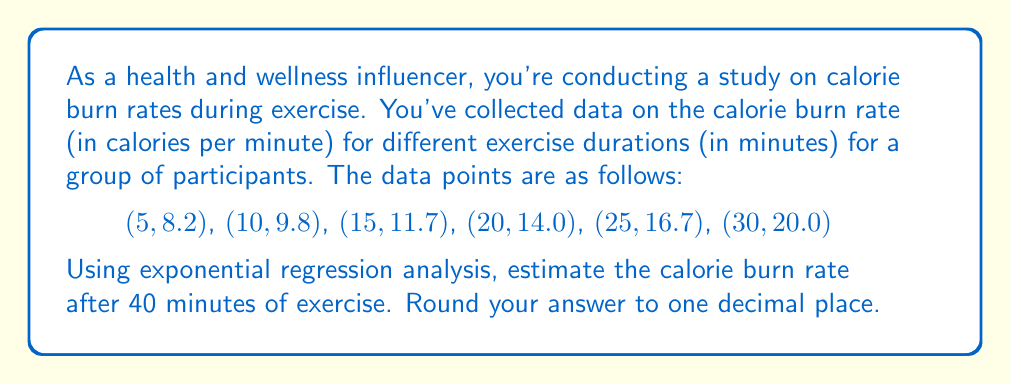Teach me how to tackle this problem. To solve this problem, we'll use exponential regression analysis to fit an exponential model to the given data points. The general form of the exponential model is:

$$y = ae^{bx}$$

Where $y$ is the calorie burn rate, $x$ is the exercise duration, and $a$ and $b$ are constants we need to determine.

Step 1: Linearize the exponential model by taking the natural logarithm of both sides:
$$\ln(y) = \ln(a) + bx$$

Step 2: Let $Y = \ln(y)$ and $A = \ln(a)$. Now we have a linear equation:
$$Y = A + bx$$

Step 3: Calculate the necessary sums for linear regression:
$$\sum x = 105, \sum Y = 16.2747, \sum x^2 = 2975, \sum xY = 348.5985, n = 6$$

Step 4: Use the linear regression formulas to find $b$ and $A$:

$$b = \frac{n\sum xY - \sum x \sum Y}{n\sum x^2 - (\sum x)^2} = 0.0296$$

$$A = \frac{\sum Y}{n} - b\frac{\sum x}{n} = 1.9043$$

Step 5: Calculate $a$:
$$a = e^A = e^{1.9043} = 6.7137$$

Step 6: Our exponential regression model is:
$$y = 6.7137e^{0.0296x}$$

Step 7: Estimate the calorie burn rate at 40 minutes:
$$y = 6.7137e^{0.0296(40)} = 23.9559$$

Step 8: Round to one decimal place: 23.9559 ≈ 24.0
Answer: 24.0 calories per minute 